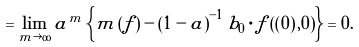Convert formula to latex. <formula><loc_0><loc_0><loc_500><loc_500>= \lim _ { m \rightarrow \infty } a ^ { m } \left \{ m \left ( f \right ) - \left ( 1 - a \right ) ^ { - 1 } b _ { 0 } \cdot f \left ( \left ( 0 \right ) , 0 \right ) \right \} = 0 .</formula> 